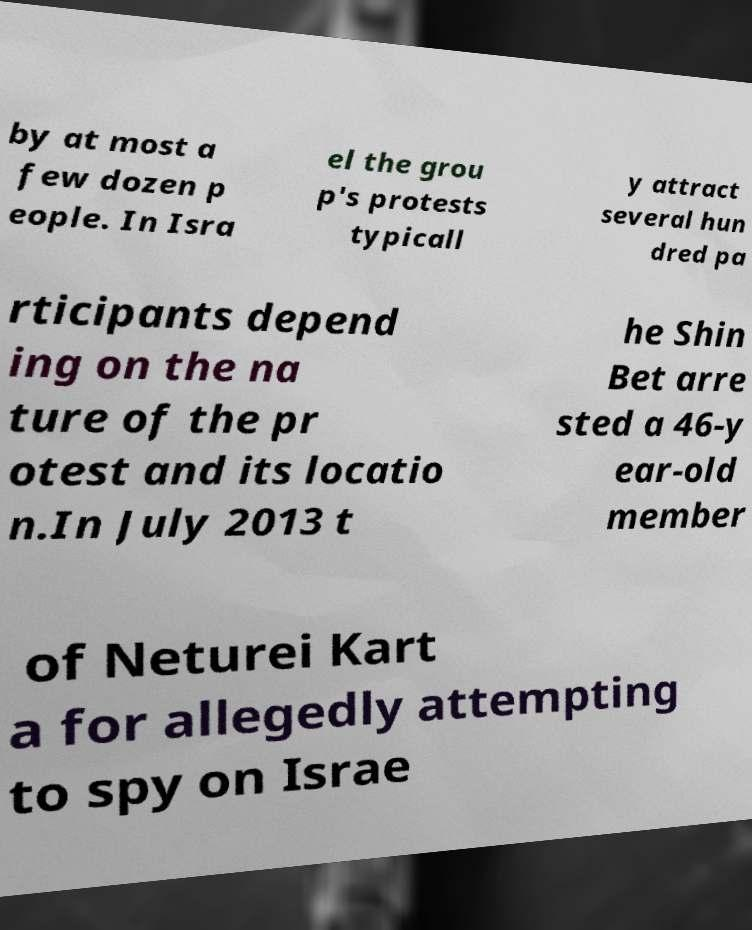For documentation purposes, I need the text within this image transcribed. Could you provide that? by at most a few dozen p eople. In Isra el the grou p's protests typicall y attract several hun dred pa rticipants depend ing on the na ture of the pr otest and its locatio n.In July 2013 t he Shin Bet arre sted a 46-y ear-old member of Neturei Kart a for allegedly attempting to spy on Israe 